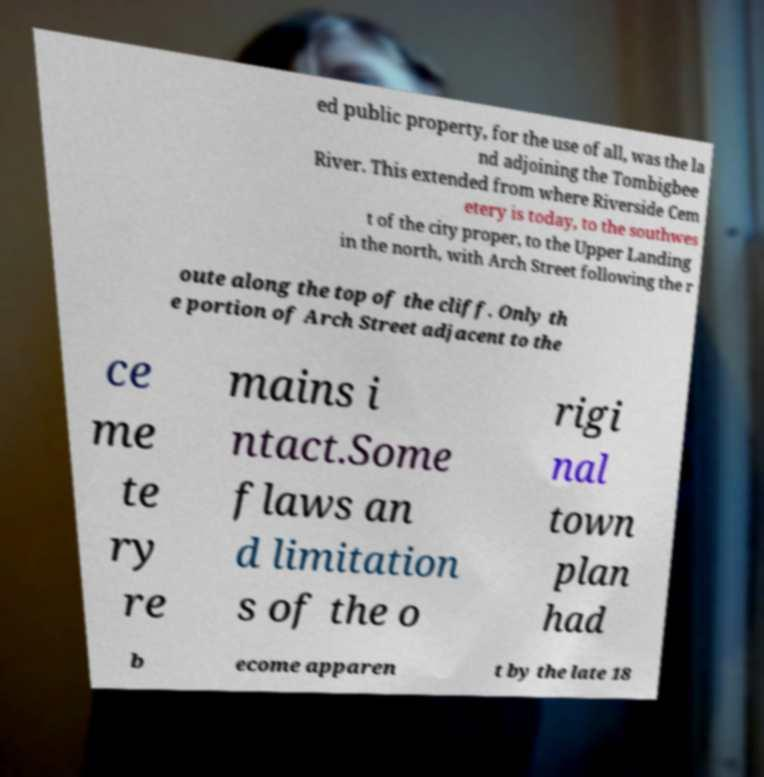Could you extract and type out the text from this image? ed public property, for the use of all, was the la nd adjoining the Tombigbee River. This extended from where Riverside Cem etery is today, to the southwes t of the city proper, to the Upper Landing in the north, with Arch Street following the r oute along the top of the cliff. Only th e portion of Arch Street adjacent to the ce me te ry re mains i ntact.Some flaws an d limitation s of the o rigi nal town plan had b ecome apparen t by the late 18 